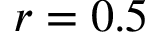Convert formula to latex. <formula><loc_0><loc_0><loc_500><loc_500>r = 0 . 5</formula> 